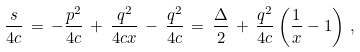<formula> <loc_0><loc_0><loc_500><loc_500>\frac { s } { 4 c } \, = \, - \frac { p ^ { 2 } } { 4 c } \, + \, \frac { q ^ { 2 } } { 4 c x } \, - \, \frac { q ^ { 2 } } { 4 c } \, = \, \frac { \Delta } { 2 } \, + \, \frac { q ^ { 2 } } { 4 c } \left ( \frac { 1 } { x } - 1 \right ) \, ,</formula> 